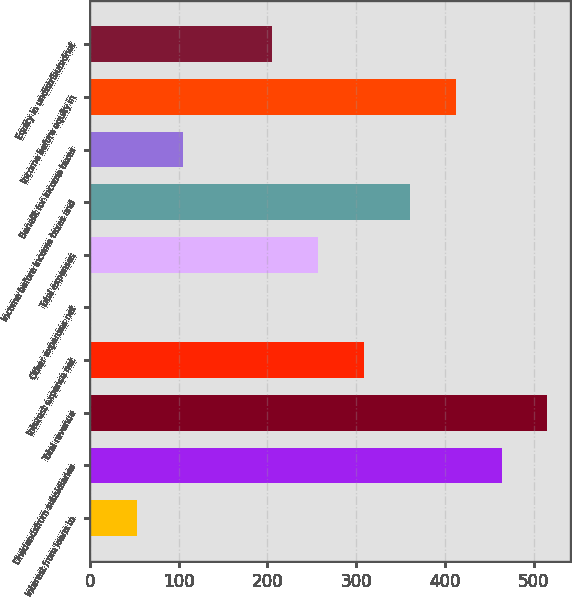Convert chart to OTSL. <chart><loc_0><loc_0><loc_500><loc_500><bar_chart><fcel>Interest from loans to<fcel>Dividendsfrom subsidiaries<fcel>Total revenue<fcel>Interest expense net<fcel>Other expenses net<fcel>Total expenses<fcel>Income before income taxes and<fcel>Benefit for income taxes<fcel>Income before equity in<fcel>Equity in undistributednet<nl><fcel>52.93<fcel>463.95<fcel>515.58<fcel>309.06<fcel>1.3<fcel>257.43<fcel>360.69<fcel>104.56<fcel>412.32<fcel>205.8<nl></chart> 